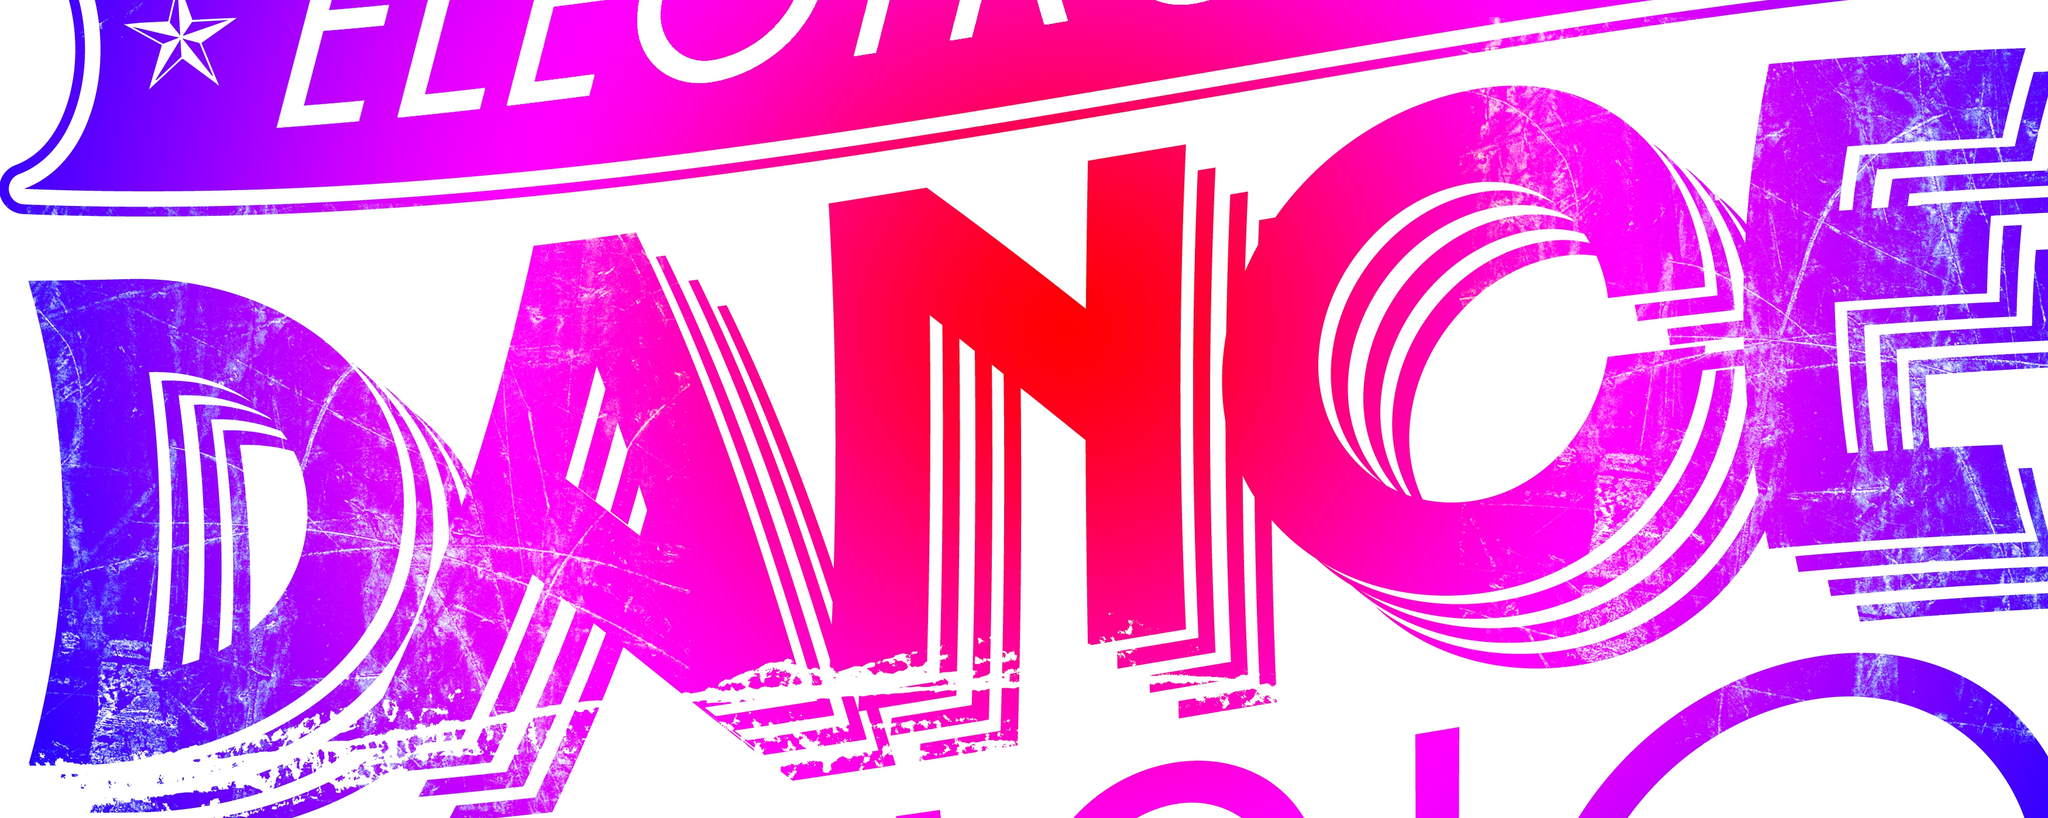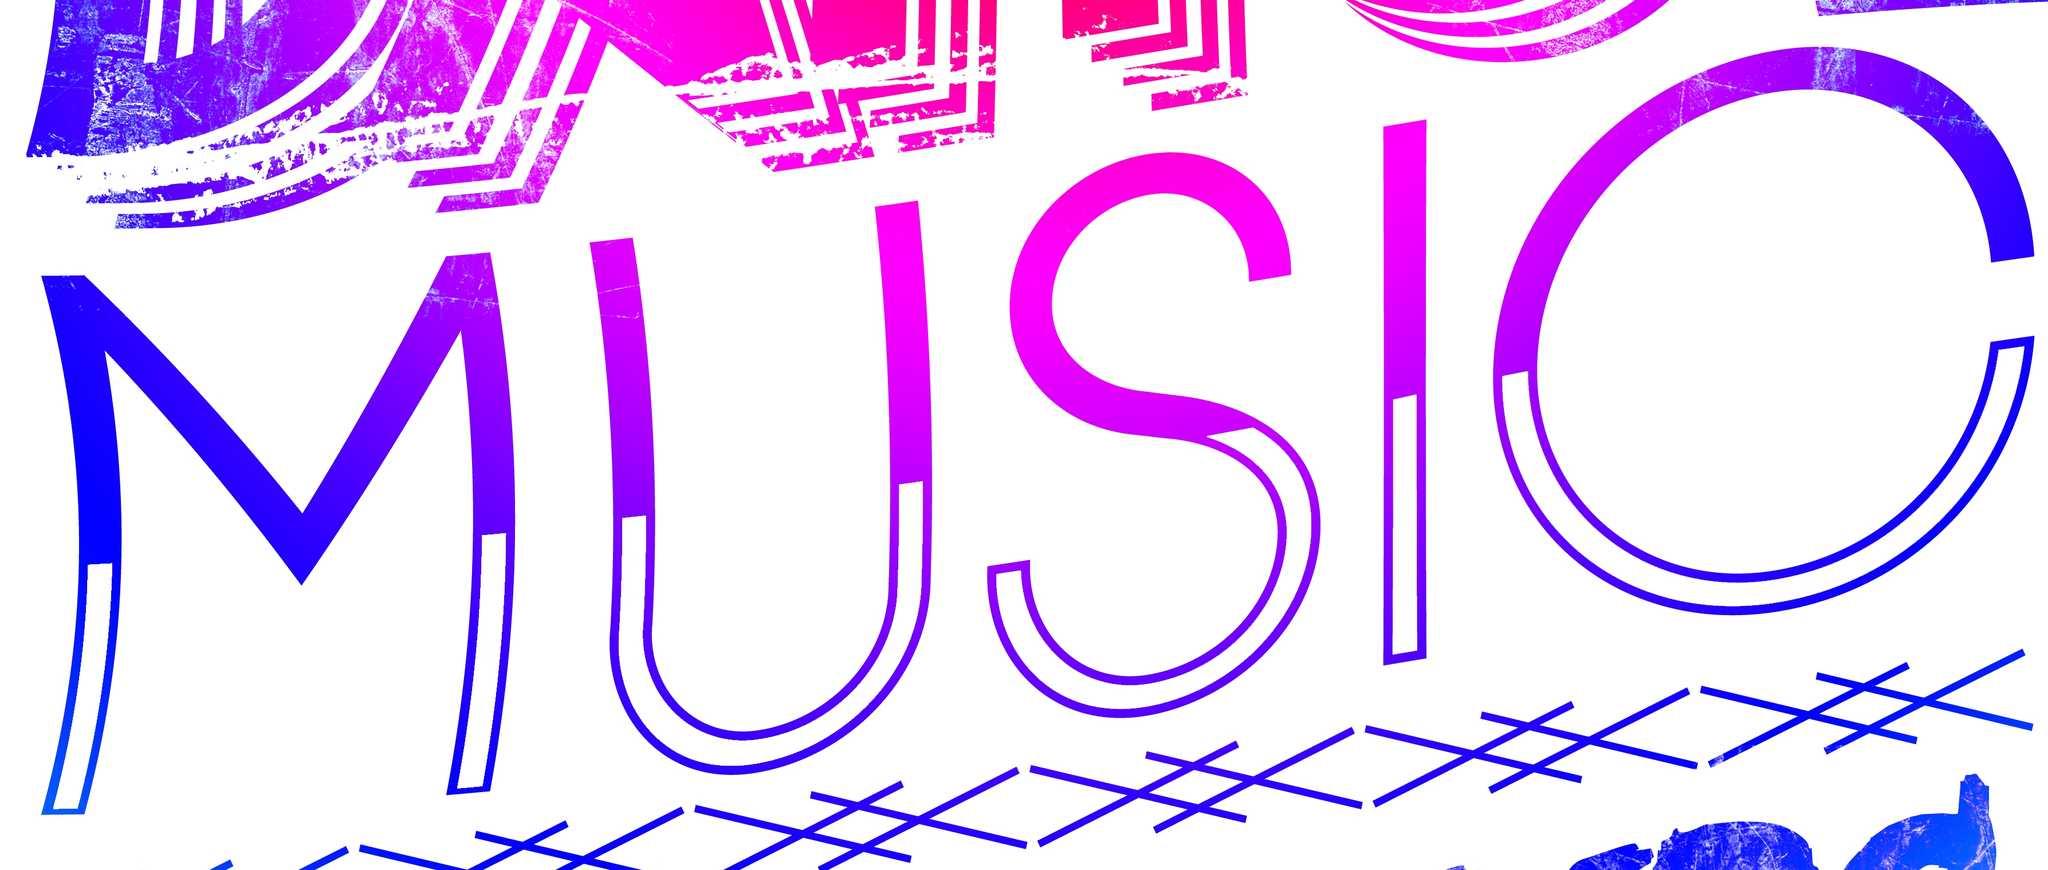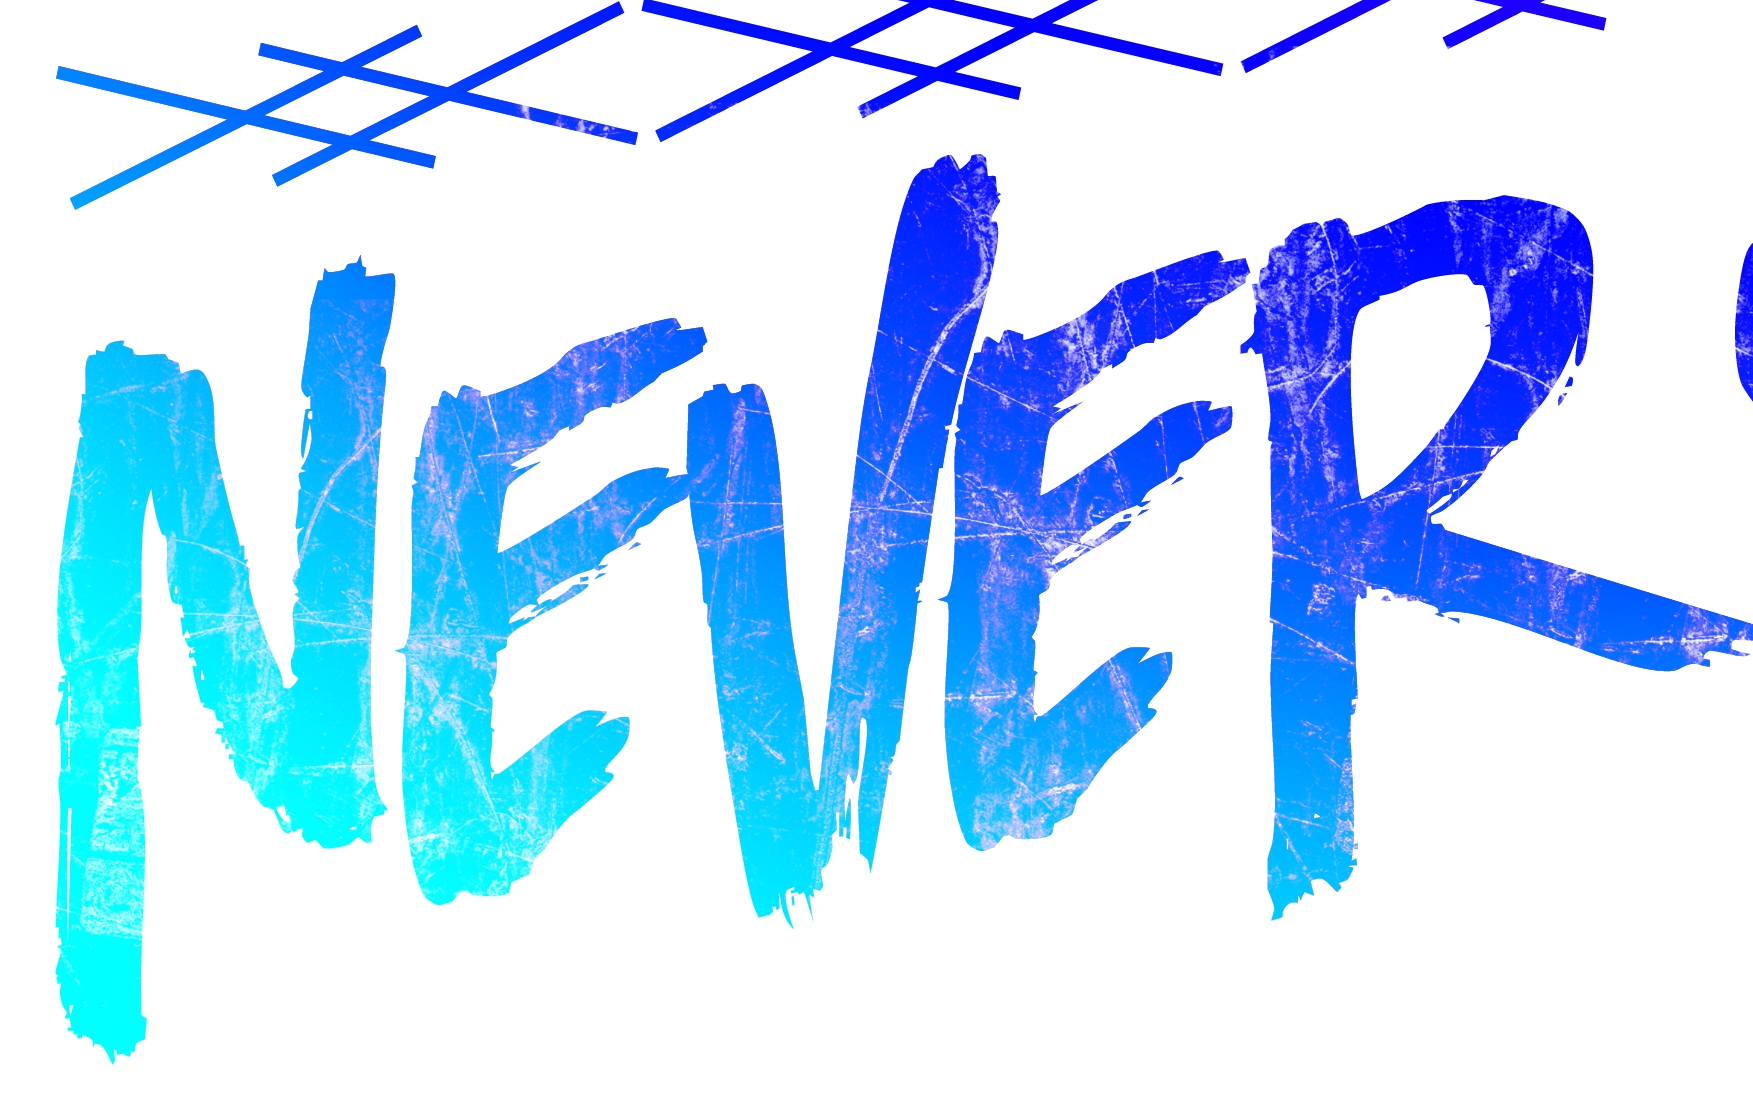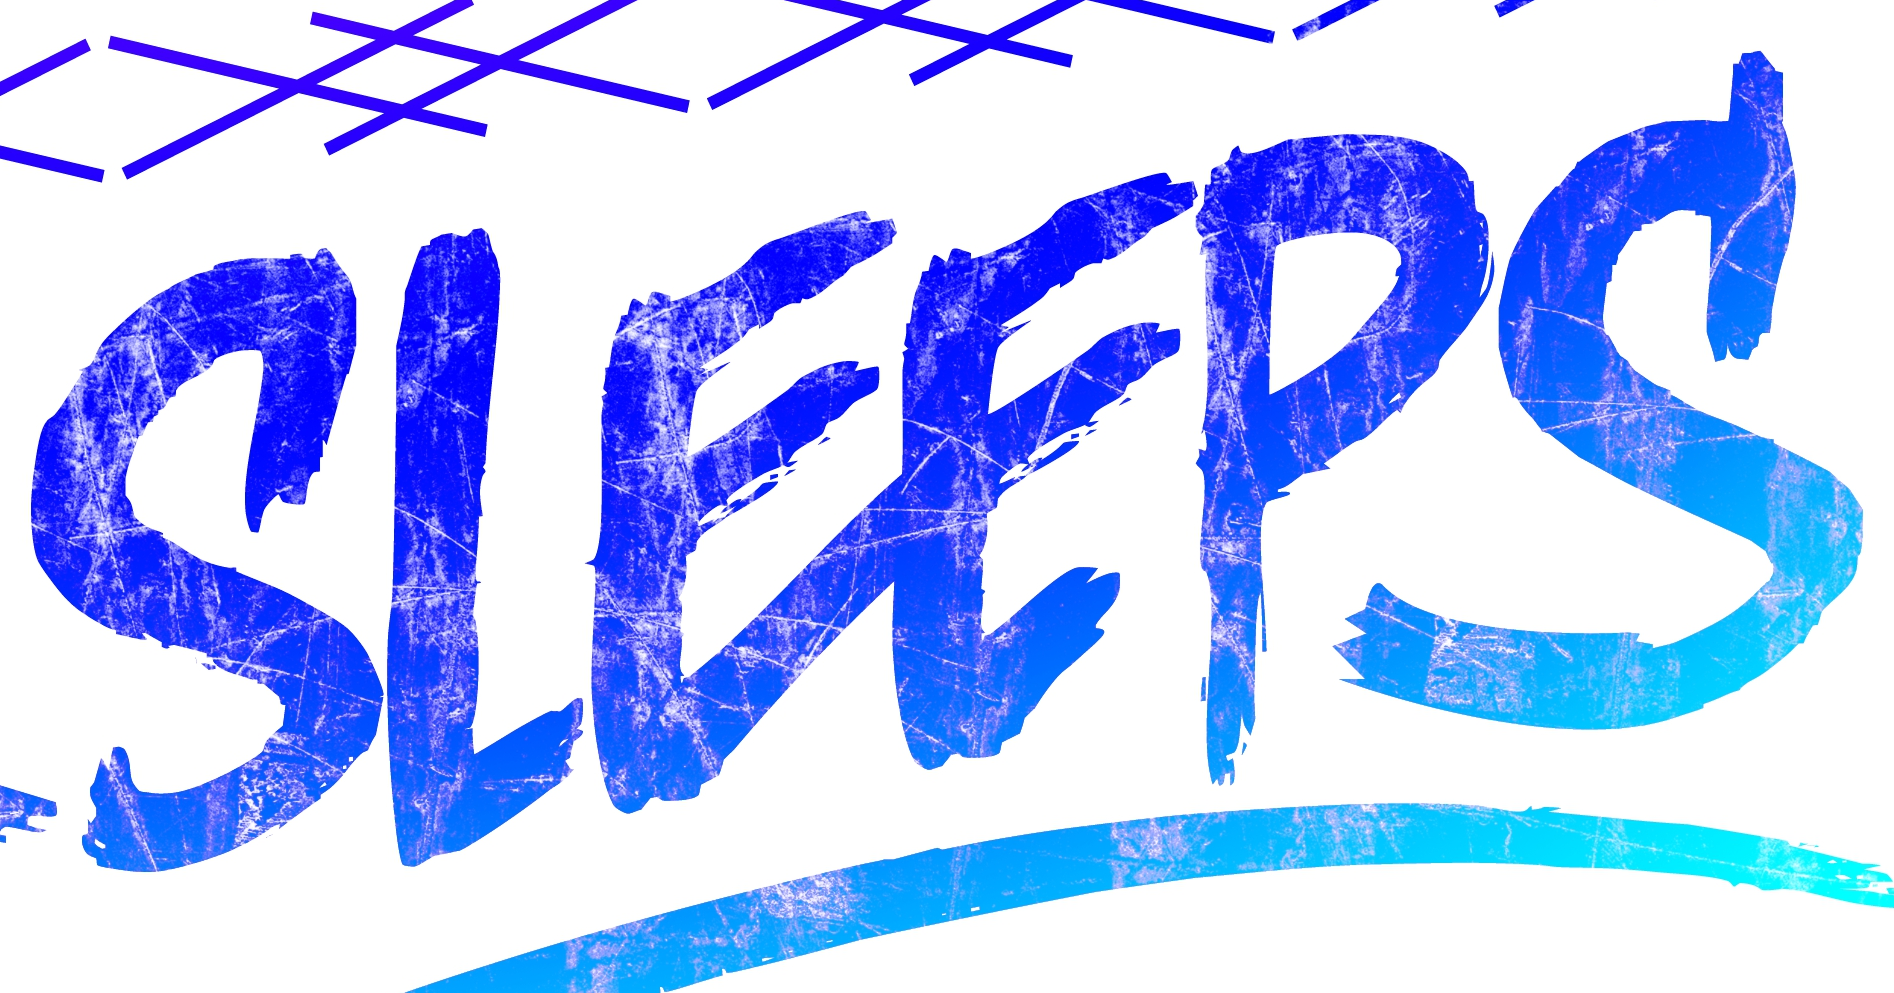Read the text from these images in sequence, separated by a semicolon. DANCE; MUSIC; NEVER; SLEEPS 